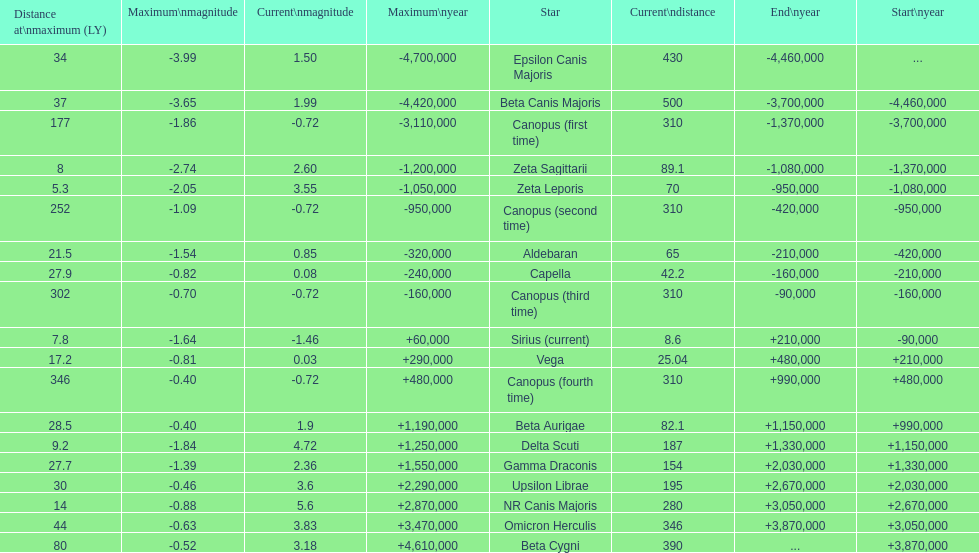How many stars possess a current magnitude not surpassing zero? 5. 